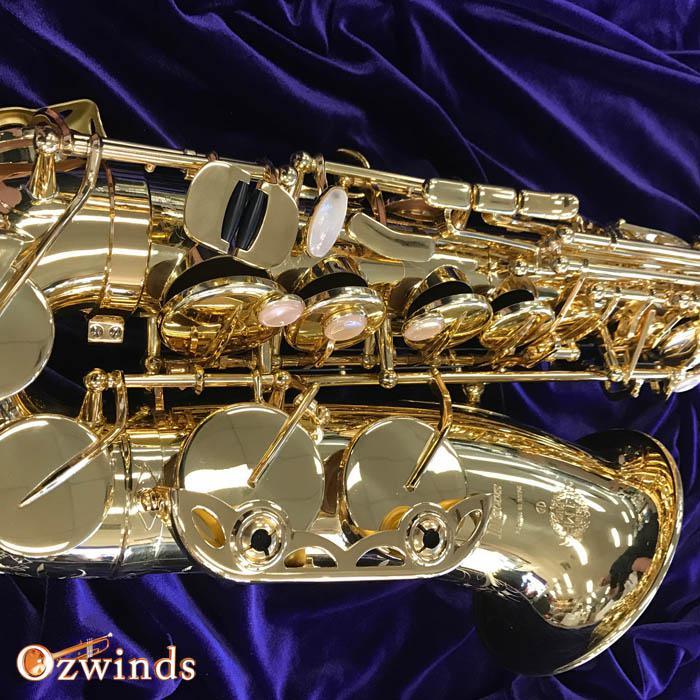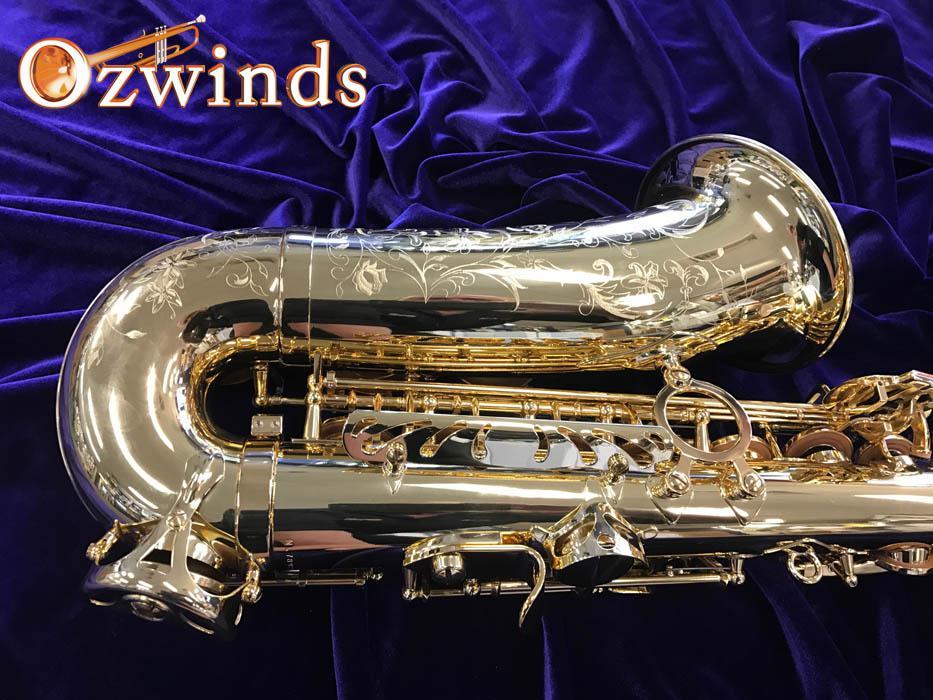The first image is the image on the left, the second image is the image on the right. Considering the images on both sides, is "Each image shows a saxophone displayed on folds of blue velvet, and in one image, the bell end of the saxophone is visible and facing upward." valid? Answer yes or no. Yes. 